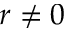Convert formula to latex. <formula><loc_0><loc_0><loc_500><loc_500>r \neq 0</formula> 